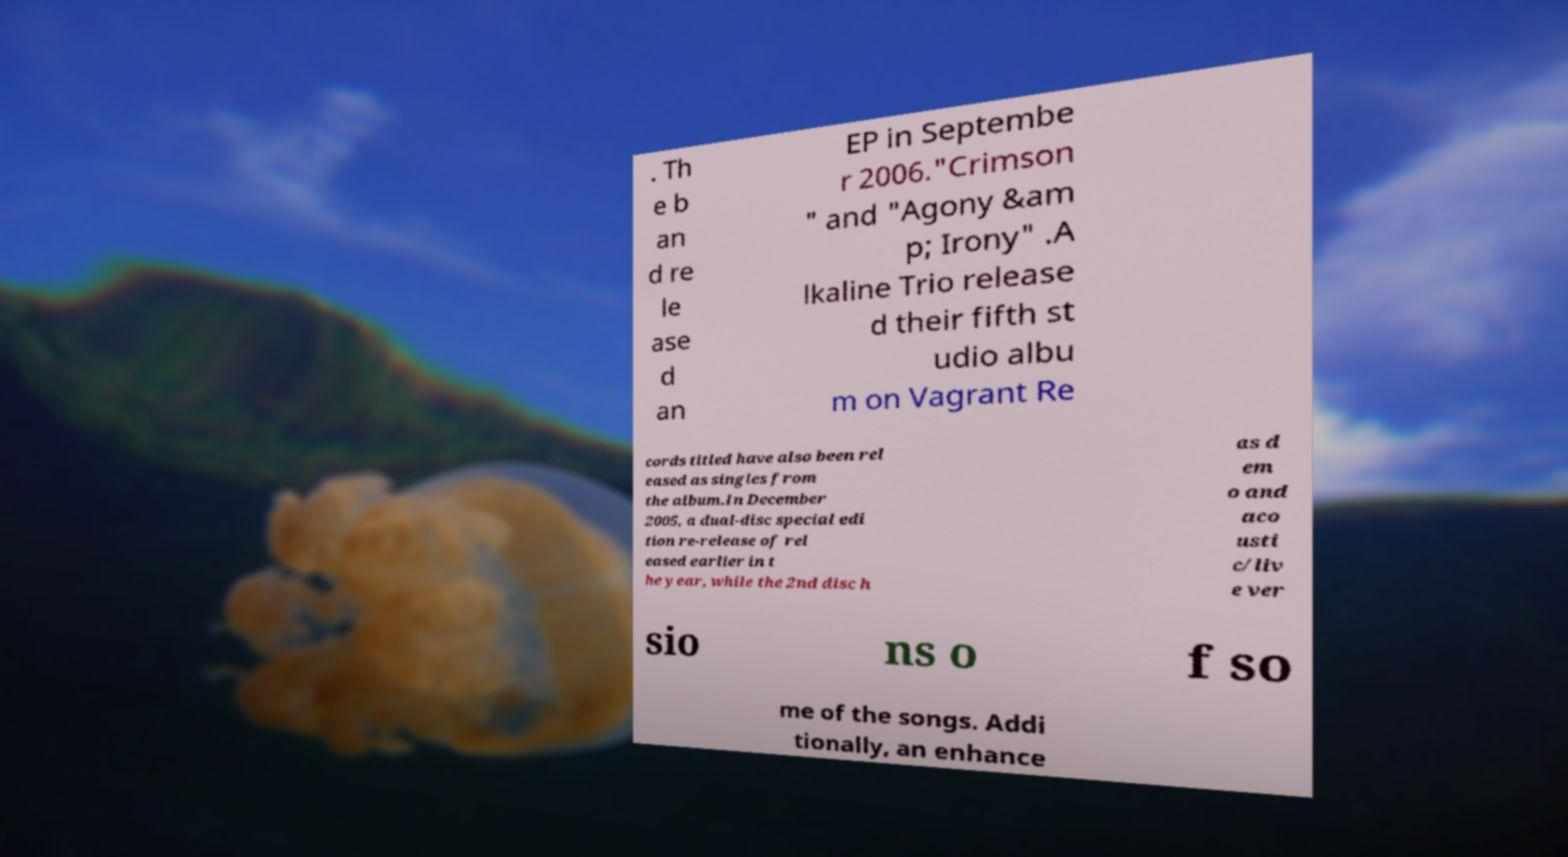Could you extract and type out the text from this image? . Th e b an d re le ase d an EP in Septembe r 2006."Crimson " and "Agony &am p; Irony" .A lkaline Trio release d their fifth st udio albu m on Vagrant Re cords titled have also been rel eased as singles from the album.In December 2005, a dual-disc special edi tion re-release of rel eased earlier in t he year, while the 2nd disc h as d em o and aco usti c/liv e ver sio ns o f so me of the songs. Addi tionally, an enhance 